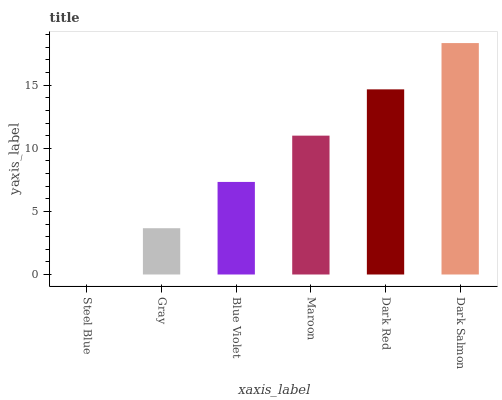Is Gray the minimum?
Answer yes or no. No. Is Gray the maximum?
Answer yes or no. No. Is Gray greater than Steel Blue?
Answer yes or no. Yes. Is Steel Blue less than Gray?
Answer yes or no. Yes. Is Steel Blue greater than Gray?
Answer yes or no. No. Is Gray less than Steel Blue?
Answer yes or no. No. Is Maroon the high median?
Answer yes or no. Yes. Is Blue Violet the low median?
Answer yes or no. Yes. Is Gray the high median?
Answer yes or no. No. Is Maroon the low median?
Answer yes or no. No. 